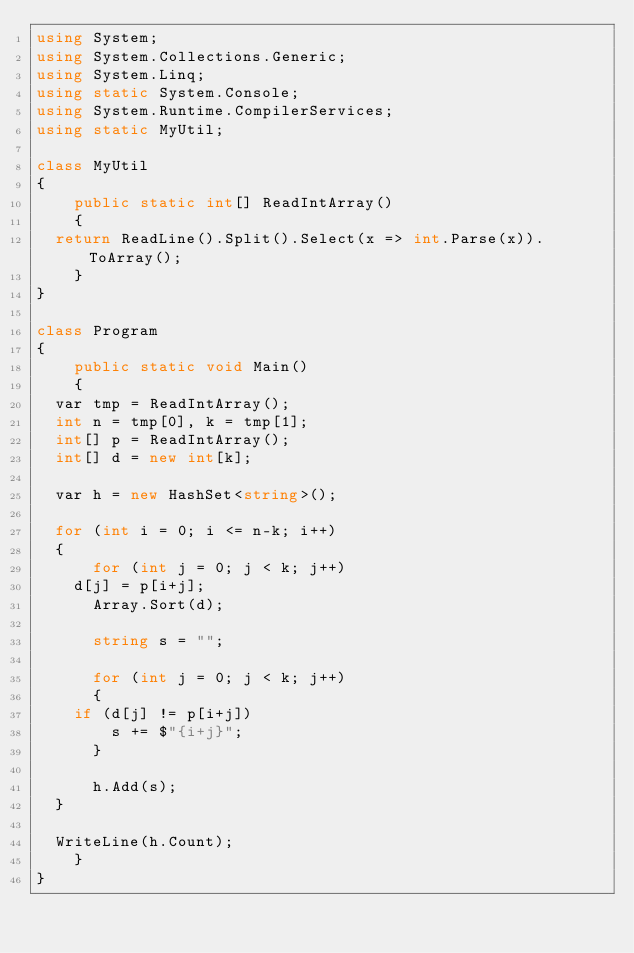<code> <loc_0><loc_0><loc_500><loc_500><_C#_>using System;
using System.Collections.Generic;
using System.Linq;
using static System.Console;
using System.Runtime.CompilerServices;
using static MyUtil;

class MyUtil
{
    public static int[] ReadIntArray()
    {
	return ReadLine().Split().Select(x => int.Parse(x)).ToArray();
    }
}

class Program
{
    public static void Main()
    {
	var tmp = ReadIntArray();
	int n = tmp[0], k = tmp[1];
	int[] p = ReadIntArray();
	int[] d = new int[k];

	var h = new HashSet<string>();
	
	for (int i = 0; i <= n-k; i++)
	{
	    for (int j = 0; j < k; j++)
		d[j] = p[i+j];
	    Array.Sort(d);

	    string s = "";

	    for (int j = 0; j < k; j++)
	    {
		if (d[j] != p[i+j])
		    s += $"{i+j}";
	    }

	    h.Add(s);
	}

	WriteLine(h.Count);
    }
}
</code> 